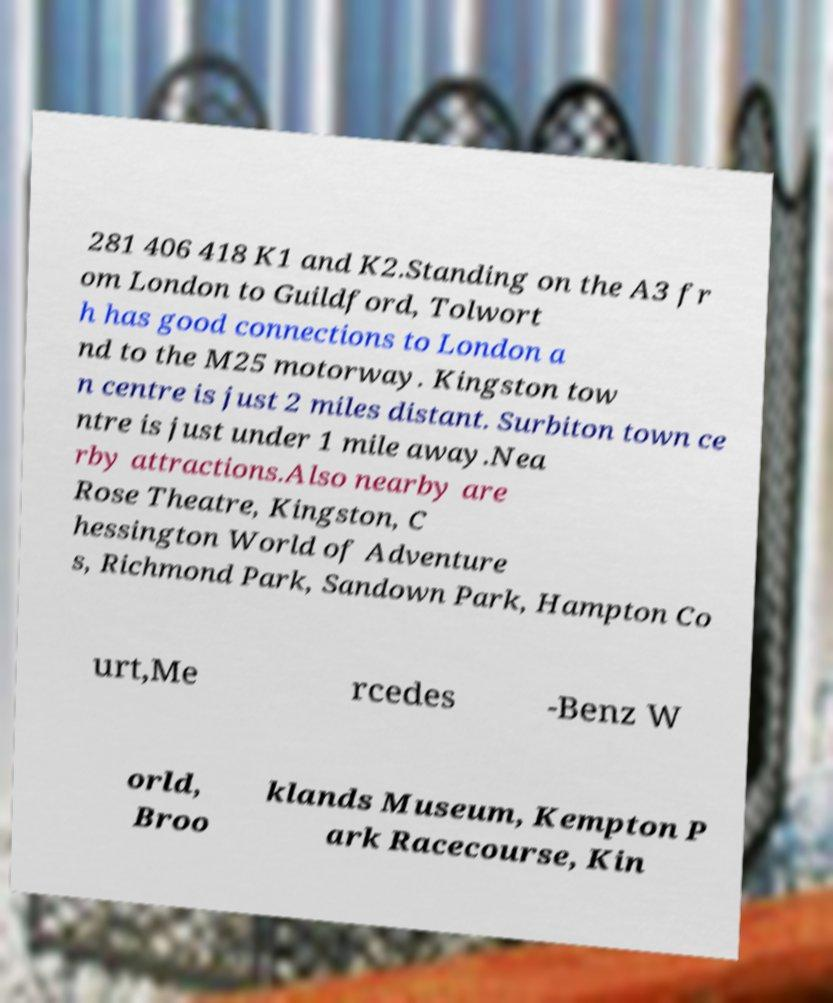Could you extract and type out the text from this image? 281 406 418 K1 and K2.Standing on the A3 fr om London to Guildford, Tolwort h has good connections to London a nd to the M25 motorway. Kingston tow n centre is just 2 miles distant. Surbiton town ce ntre is just under 1 mile away.Nea rby attractions.Also nearby are Rose Theatre, Kingston, C hessington World of Adventure s, Richmond Park, Sandown Park, Hampton Co urt,Me rcedes -Benz W orld, Broo klands Museum, Kempton P ark Racecourse, Kin 